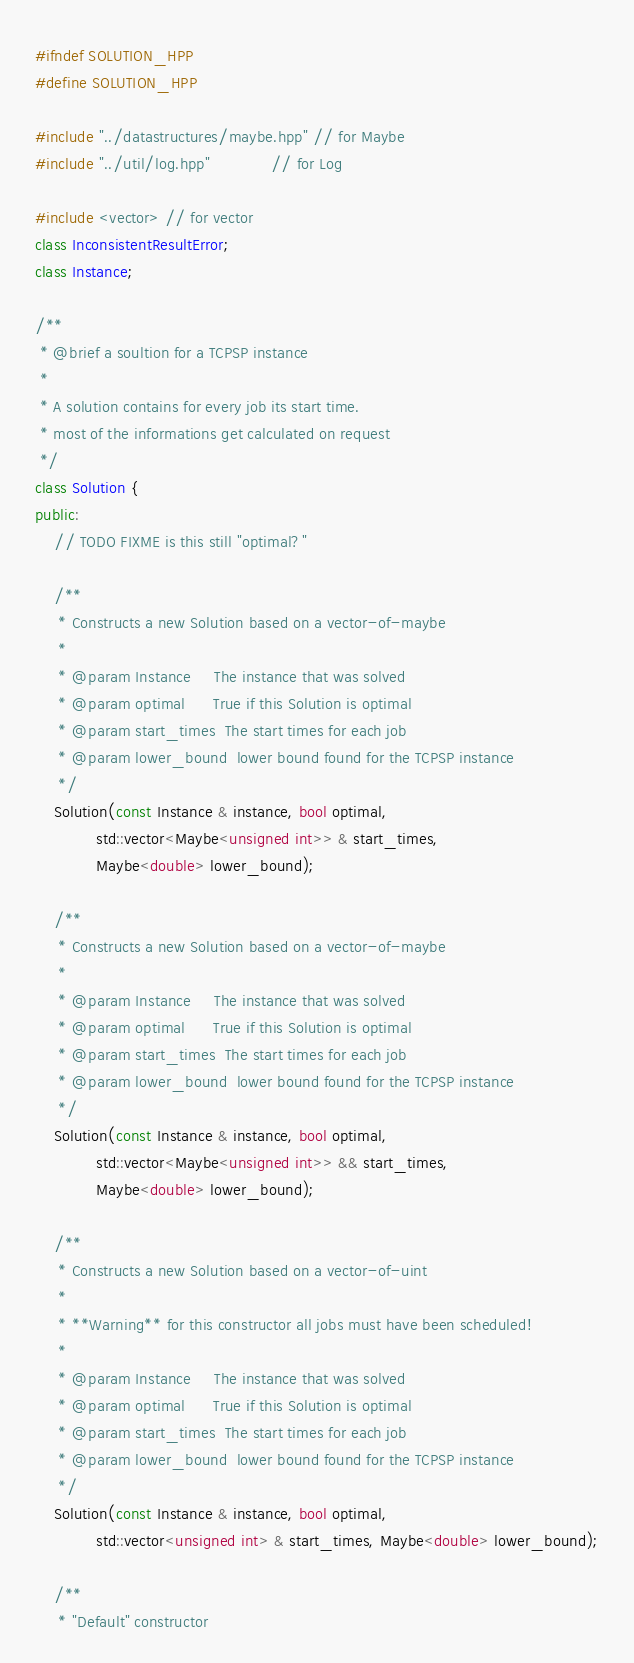<code> <loc_0><loc_0><loc_500><loc_500><_C++_>#ifndef SOLUTION_HPP
#define SOLUTION_HPP

#include "../datastructures/maybe.hpp" // for Maybe
#include "../util/log.hpp"             // for Log

#include <vector> // for vector
class InconsistentResultError;
class Instance;

/**
 * @brief a soultion for a TCPSP instance
 *
 * A solution contains for every job its start time.
 * most of the informations get calculated on request
 */
class Solution {
public:
	// TODO FIXME is this still "optimal?"

	/**
	 * Constructs a new Solution based on a vector-of-maybe
	 *
	 * @param Instance     The instance that was solved
	 * @param optimal      True if this Solution is optimal
	 * @param start_times  The start times for each job
	 * @param lower_bound  lower bound found for the TCPSP instance
	 */
	Solution(const Instance & instance, bool optimal,
	         std::vector<Maybe<unsigned int>> & start_times,
	         Maybe<double> lower_bound);

	/**
	 * Constructs a new Solution based on a vector-of-maybe
	 *
	 * @param Instance     The instance that was solved
	 * @param optimal      True if this Solution is optimal
	 * @param start_times  The start times for each job
	 * @param lower_bound  lower bound found for the TCPSP instance
	 */
	Solution(const Instance & instance, bool optimal,
	         std::vector<Maybe<unsigned int>> && start_times,
	         Maybe<double> lower_bound);

	/**
	 * Constructs a new Solution based on a vector-of-uint
	 *
	 * **Warning** for this constructor all jobs must have been scheduled!
	 *
	 * @param Instance     The instance that was solved
	 * @param optimal      True if this Solution is optimal
	 * @param start_times  The start times for each job
	 * @param lower_bound  lower bound found for the TCPSP instance
	 */
	Solution(const Instance & instance, bool optimal,
	         std::vector<unsigned int> & start_times, Maybe<double> lower_bound);

	/**
	 * "Default" constructor</code> 